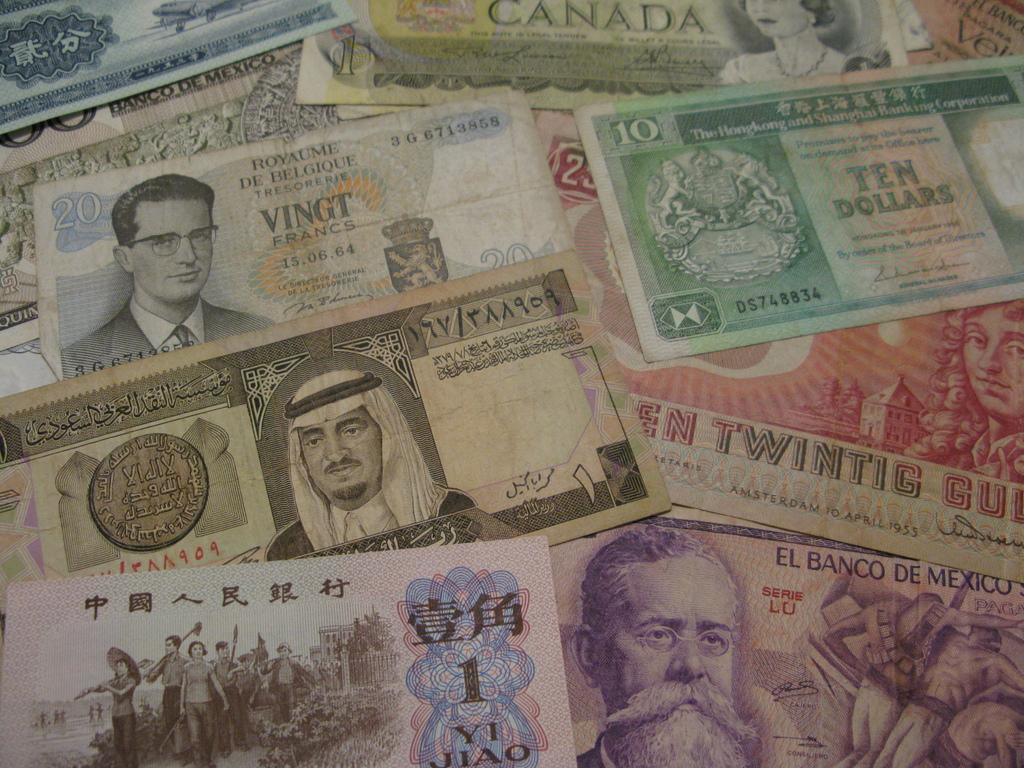What type of items can be seen in the image? Currency notes are visible in the image. What is the temper of the person holding the currency notes in the image? There is no person holding the currency notes in the image, and therefore no temper can be determined. 